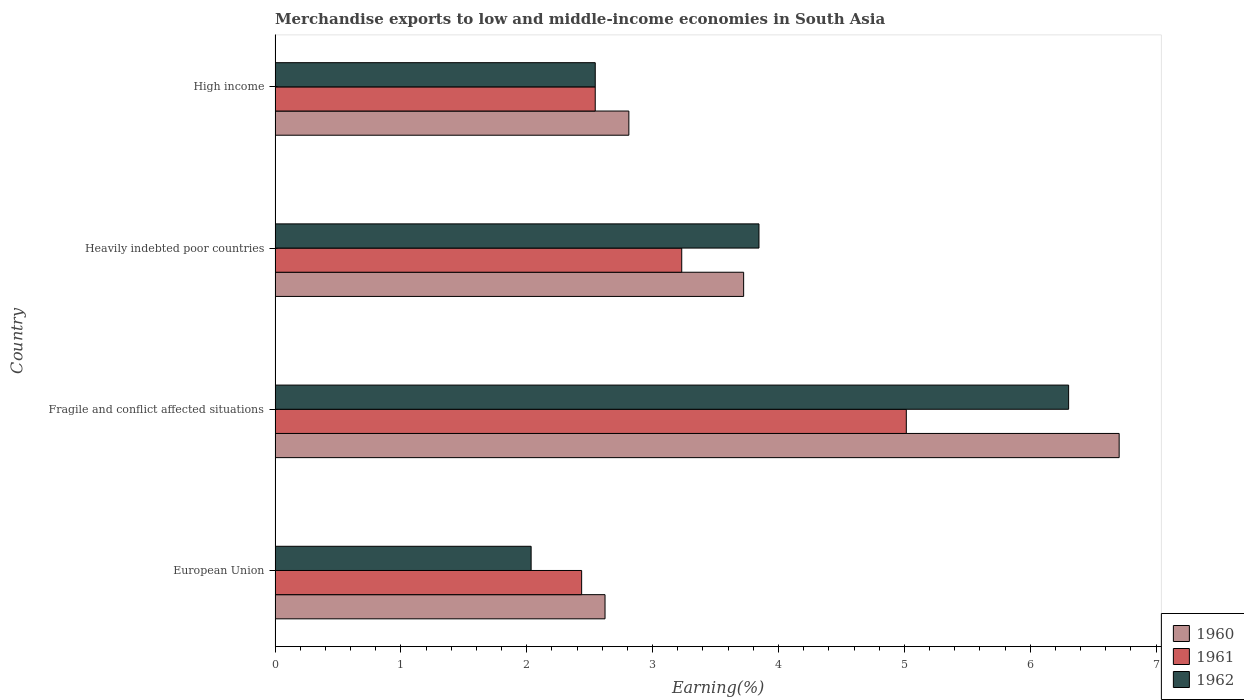How many different coloured bars are there?
Ensure brevity in your answer.  3. Are the number of bars on each tick of the Y-axis equal?
Offer a terse response. Yes. How many bars are there on the 3rd tick from the top?
Your response must be concise. 3. What is the label of the 4th group of bars from the top?
Provide a short and direct response. European Union. What is the percentage of amount earned from merchandise exports in 1962 in Fragile and conflict affected situations?
Keep it short and to the point. 6.31. Across all countries, what is the maximum percentage of amount earned from merchandise exports in 1961?
Your response must be concise. 5.02. Across all countries, what is the minimum percentage of amount earned from merchandise exports in 1961?
Provide a succinct answer. 2.44. In which country was the percentage of amount earned from merchandise exports in 1960 maximum?
Provide a succinct answer. Fragile and conflict affected situations. What is the total percentage of amount earned from merchandise exports in 1962 in the graph?
Your response must be concise. 14.73. What is the difference between the percentage of amount earned from merchandise exports in 1961 in European Union and that in Heavily indebted poor countries?
Make the answer very short. -0.8. What is the difference between the percentage of amount earned from merchandise exports in 1962 in Heavily indebted poor countries and the percentage of amount earned from merchandise exports in 1960 in Fragile and conflict affected situations?
Your response must be concise. -2.86. What is the average percentage of amount earned from merchandise exports in 1961 per country?
Your response must be concise. 3.31. What is the difference between the percentage of amount earned from merchandise exports in 1962 and percentage of amount earned from merchandise exports in 1960 in High income?
Offer a very short reply. -0.27. What is the ratio of the percentage of amount earned from merchandise exports in 1960 in Heavily indebted poor countries to that in High income?
Your answer should be very brief. 1.32. Is the percentage of amount earned from merchandise exports in 1960 in European Union less than that in Fragile and conflict affected situations?
Provide a short and direct response. Yes. Is the difference between the percentage of amount earned from merchandise exports in 1962 in European Union and High income greater than the difference between the percentage of amount earned from merchandise exports in 1960 in European Union and High income?
Provide a short and direct response. No. What is the difference between the highest and the second highest percentage of amount earned from merchandise exports in 1960?
Offer a terse response. 2.98. What is the difference between the highest and the lowest percentage of amount earned from merchandise exports in 1961?
Provide a short and direct response. 2.58. Is it the case that in every country, the sum of the percentage of amount earned from merchandise exports in 1962 and percentage of amount earned from merchandise exports in 1961 is greater than the percentage of amount earned from merchandise exports in 1960?
Make the answer very short. Yes. Are all the bars in the graph horizontal?
Provide a succinct answer. Yes. Does the graph contain grids?
Offer a terse response. No. Where does the legend appear in the graph?
Give a very brief answer. Bottom right. What is the title of the graph?
Give a very brief answer. Merchandise exports to low and middle-income economies in South Asia. Does "1966" appear as one of the legend labels in the graph?
Give a very brief answer. No. What is the label or title of the X-axis?
Make the answer very short. Earning(%). What is the label or title of the Y-axis?
Provide a short and direct response. Country. What is the Earning(%) in 1960 in European Union?
Offer a very short reply. 2.62. What is the Earning(%) of 1961 in European Union?
Offer a terse response. 2.44. What is the Earning(%) in 1962 in European Union?
Your answer should be very brief. 2.03. What is the Earning(%) of 1960 in Fragile and conflict affected situations?
Provide a succinct answer. 6.71. What is the Earning(%) of 1961 in Fragile and conflict affected situations?
Your answer should be very brief. 5.02. What is the Earning(%) of 1962 in Fragile and conflict affected situations?
Provide a short and direct response. 6.31. What is the Earning(%) in 1960 in Heavily indebted poor countries?
Your answer should be very brief. 3.72. What is the Earning(%) of 1961 in Heavily indebted poor countries?
Ensure brevity in your answer.  3.23. What is the Earning(%) in 1962 in Heavily indebted poor countries?
Provide a succinct answer. 3.84. What is the Earning(%) of 1960 in High income?
Ensure brevity in your answer.  2.81. What is the Earning(%) of 1961 in High income?
Give a very brief answer. 2.54. What is the Earning(%) in 1962 in High income?
Offer a terse response. 2.54. Across all countries, what is the maximum Earning(%) of 1960?
Provide a short and direct response. 6.71. Across all countries, what is the maximum Earning(%) of 1961?
Provide a succinct answer. 5.02. Across all countries, what is the maximum Earning(%) of 1962?
Provide a succinct answer. 6.31. Across all countries, what is the minimum Earning(%) of 1960?
Provide a succinct answer. 2.62. Across all countries, what is the minimum Earning(%) in 1961?
Make the answer very short. 2.44. Across all countries, what is the minimum Earning(%) of 1962?
Your answer should be very brief. 2.03. What is the total Earning(%) in 1960 in the graph?
Offer a terse response. 15.86. What is the total Earning(%) in 1961 in the graph?
Your answer should be compact. 13.23. What is the total Earning(%) in 1962 in the graph?
Ensure brevity in your answer.  14.73. What is the difference between the Earning(%) of 1960 in European Union and that in Fragile and conflict affected situations?
Provide a short and direct response. -4.09. What is the difference between the Earning(%) in 1961 in European Union and that in Fragile and conflict affected situations?
Give a very brief answer. -2.58. What is the difference between the Earning(%) of 1962 in European Union and that in Fragile and conflict affected situations?
Provide a succinct answer. -4.27. What is the difference between the Earning(%) in 1960 in European Union and that in Heavily indebted poor countries?
Your answer should be compact. -1.1. What is the difference between the Earning(%) in 1961 in European Union and that in Heavily indebted poor countries?
Your answer should be compact. -0.8. What is the difference between the Earning(%) in 1962 in European Union and that in Heavily indebted poor countries?
Provide a succinct answer. -1.81. What is the difference between the Earning(%) in 1960 in European Union and that in High income?
Provide a succinct answer. -0.19. What is the difference between the Earning(%) in 1961 in European Union and that in High income?
Make the answer very short. -0.11. What is the difference between the Earning(%) in 1962 in European Union and that in High income?
Make the answer very short. -0.51. What is the difference between the Earning(%) of 1960 in Fragile and conflict affected situations and that in Heavily indebted poor countries?
Offer a terse response. 2.98. What is the difference between the Earning(%) of 1961 in Fragile and conflict affected situations and that in Heavily indebted poor countries?
Keep it short and to the point. 1.78. What is the difference between the Earning(%) in 1962 in Fragile and conflict affected situations and that in Heavily indebted poor countries?
Your answer should be compact. 2.46. What is the difference between the Earning(%) in 1960 in Fragile and conflict affected situations and that in High income?
Keep it short and to the point. 3.9. What is the difference between the Earning(%) of 1961 in Fragile and conflict affected situations and that in High income?
Provide a succinct answer. 2.47. What is the difference between the Earning(%) of 1962 in Fragile and conflict affected situations and that in High income?
Offer a very short reply. 3.76. What is the difference between the Earning(%) in 1960 in Heavily indebted poor countries and that in High income?
Your answer should be very brief. 0.91. What is the difference between the Earning(%) in 1961 in Heavily indebted poor countries and that in High income?
Ensure brevity in your answer.  0.69. What is the difference between the Earning(%) of 1962 in Heavily indebted poor countries and that in High income?
Your response must be concise. 1.3. What is the difference between the Earning(%) in 1960 in European Union and the Earning(%) in 1961 in Fragile and conflict affected situations?
Provide a short and direct response. -2.39. What is the difference between the Earning(%) in 1960 in European Union and the Earning(%) in 1962 in Fragile and conflict affected situations?
Provide a short and direct response. -3.68. What is the difference between the Earning(%) in 1961 in European Union and the Earning(%) in 1962 in Fragile and conflict affected situations?
Offer a very short reply. -3.87. What is the difference between the Earning(%) in 1960 in European Union and the Earning(%) in 1961 in Heavily indebted poor countries?
Give a very brief answer. -0.61. What is the difference between the Earning(%) in 1960 in European Union and the Earning(%) in 1962 in Heavily indebted poor countries?
Make the answer very short. -1.22. What is the difference between the Earning(%) in 1961 in European Union and the Earning(%) in 1962 in Heavily indebted poor countries?
Keep it short and to the point. -1.41. What is the difference between the Earning(%) in 1960 in European Union and the Earning(%) in 1961 in High income?
Offer a terse response. 0.08. What is the difference between the Earning(%) of 1960 in European Union and the Earning(%) of 1962 in High income?
Provide a succinct answer. 0.08. What is the difference between the Earning(%) of 1961 in European Union and the Earning(%) of 1962 in High income?
Offer a very short reply. -0.11. What is the difference between the Earning(%) in 1960 in Fragile and conflict affected situations and the Earning(%) in 1961 in Heavily indebted poor countries?
Offer a very short reply. 3.48. What is the difference between the Earning(%) in 1960 in Fragile and conflict affected situations and the Earning(%) in 1962 in Heavily indebted poor countries?
Your response must be concise. 2.86. What is the difference between the Earning(%) in 1961 in Fragile and conflict affected situations and the Earning(%) in 1962 in Heavily indebted poor countries?
Ensure brevity in your answer.  1.17. What is the difference between the Earning(%) in 1960 in Fragile and conflict affected situations and the Earning(%) in 1961 in High income?
Provide a succinct answer. 4.16. What is the difference between the Earning(%) in 1960 in Fragile and conflict affected situations and the Earning(%) in 1962 in High income?
Provide a succinct answer. 4.16. What is the difference between the Earning(%) in 1961 in Fragile and conflict affected situations and the Earning(%) in 1962 in High income?
Provide a succinct answer. 2.47. What is the difference between the Earning(%) in 1960 in Heavily indebted poor countries and the Earning(%) in 1961 in High income?
Offer a terse response. 1.18. What is the difference between the Earning(%) of 1960 in Heavily indebted poor countries and the Earning(%) of 1962 in High income?
Your response must be concise. 1.18. What is the difference between the Earning(%) of 1961 in Heavily indebted poor countries and the Earning(%) of 1962 in High income?
Provide a succinct answer. 0.69. What is the average Earning(%) of 1960 per country?
Offer a very short reply. 3.97. What is the average Earning(%) of 1961 per country?
Your answer should be compact. 3.31. What is the average Earning(%) in 1962 per country?
Your answer should be very brief. 3.68. What is the difference between the Earning(%) in 1960 and Earning(%) in 1961 in European Union?
Provide a succinct answer. 0.19. What is the difference between the Earning(%) in 1960 and Earning(%) in 1962 in European Union?
Give a very brief answer. 0.59. What is the difference between the Earning(%) of 1961 and Earning(%) of 1962 in European Union?
Make the answer very short. 0.4. What is the difference between the Earning(%) in 1960 and Earning(%) in 1961 in Fragile and conflict affected situations?
Ensure brevity in your answer.  1.69. What is the difference between the Earning(%) in 1960 and Earning(%) in 1962 in Fragile and conflict affected situations?
Make the answer very short. 0.4. What is the difference between the Earning(%) in 1961 and Earning(%) in 1962 in Fragile and conflict affected situations?
Offer a terse response. -1.29. What is the difference between the Earning(%) of 1960 and Earning(%) of 1961 in Heavily indebted poor countries?
Keep it short and to the point. 0.49. What is the difference between the Earning(%) in 1960 and Earning(%) in 1962 in Heavily indebted poor countries?
Your answer should be compact. -0.12. What is the difference between the Earning(%) of 1961 and Earning(%) of 1962 in Heavily indebted poor countries?
Make the answer very short. -0.61. What is the difference between the Earning(%) of 1960 and Earning(%) of 1961 in High income?
Provide a succinct answer. 0.27. What is the difference between the Earning(%) of 1960 and Earning(%) of 1962 in High income?
Your answer should be very brief. 0.27. What is the difference between the Earning(%) of 1961 and Earning(%) of 1962 in High income?
Your answer should be very brief. -0. What is the ratio of the Earning(%) of 1960 in European Union to that in Fragile and conflict affected situations?
Ensure brevity in your answer.  0.39. What is the ratio of the Earning(%) of 1961 in European Union to that in Fragile and conflict affected situations?
Your response must be concise. 0.49. What is the ratio of the Earning(%) of 1962 in European Union to that in Fragile and conflict affected situations?
Ensure brevity in your answer.  0.32. What is the ratio of the Earning(%) of 1960 in European Union to that in Heavily indebted poor countries?
Your answer should be compact. 0.7. What is the ratio of the Earning(%) of 1961 in European Union to that in Heavily indebted poor countries?
Your response must be concise. 0.75. What is the ratio of the Earning(%) in 1962 in European Union to that in Heavily indebted poor countries?
Offer a terse response. 0.53. What is the ratio of the Earning(%) of 1960 in European Union to that in High income?
Ensure brevity in your answer.  0.93. What is the ratio of the Earning(%) in 1961 in European Union to that in High income?
Your answer should be very brief. 0.96. What is the ratio of the Earning(%) of 1962 in European Union to that in High income?
Make the answer very short. 0.8. What is the ratio of the Earning(%) in 1960 in Fragile and conflict affected situations to that in Heavily indebted poor countries?
Your answer should be compact. 1.8. What is the ratio of the Earning(%) in 1961 in Fragile and conflict affected situations to that in Heavily indebted poor countries?
Keep it short and to the point. 1.55. What is the ratio of the Earning(%) in 1962 in Fragile and conflict affected situations to that in Heavily indebted poor countries?
Offer a terse response. 1.64. What is the ratio of the Earning(%) of 1960 in Fragile and conflict affected situations to that in High income?
Your answer should be compact. 2.39. What is the ratio of the Earning(%) in 1961 in Fragile and conflict affected situations to that in High income?
Make the answer very short. 1.97. What is the ratio of the Earning(%) in 1962 in Fragile and conflict affected situations to that in High income?
Keep it short and to the point. 2.48. What is the ratio of the Earning(%) in 1960 in Heavily indebted poor countries to that in High income?
Provide a short and direct response. 1.32. What is the ratio of the Earning(%) of 1961 in Heavily indebted poor countries to that in High income?
Your answer should be very brief. 1.27. What is the ratio of the Earning(%) of 1962 in Heavily indebted poor countries to that in High income?
Your response must be concise. 1.51. What is the difference between the highest and the second highest Earning(%) of 1960?
Your response must be concise. 2.98. What is the difference between the highest and the second highest Earning(%) in 1961?
Offer a very short reply. 1.78. What is the difference between the highest and the second highest Earning(%) in 1962?
Your answer should be very brief. 2.46. What is the difference between the highest and the lowest Earning(%) of 1960?
Your answer should be very brief. 4.09. What is the difference between the highest and the lowest Earning(%) of 1961?
Your answer should be compact. 2.58. What is the difference between the highest and the lowest Earning(%) in 1962?
Make the answer very short. 4.27. 